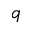Convert formula to latex. <formula><loc_0><loc_0><loc_500><loc_500>\mathfrak { q }</formula> 